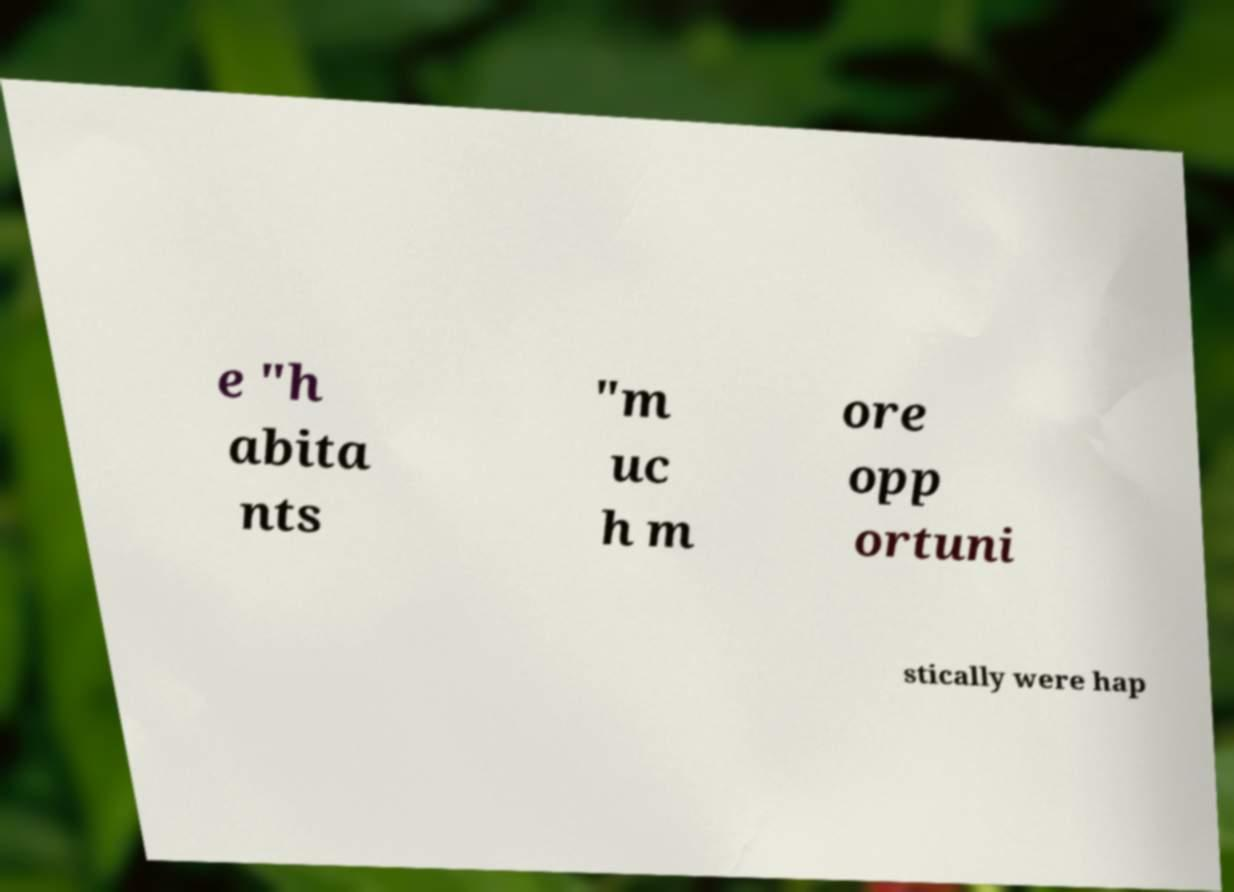Could you assist in decoding the text presented in this image and type it out clearly? e "h abita nts "m uc h m ore opp ortuni stically were hap 